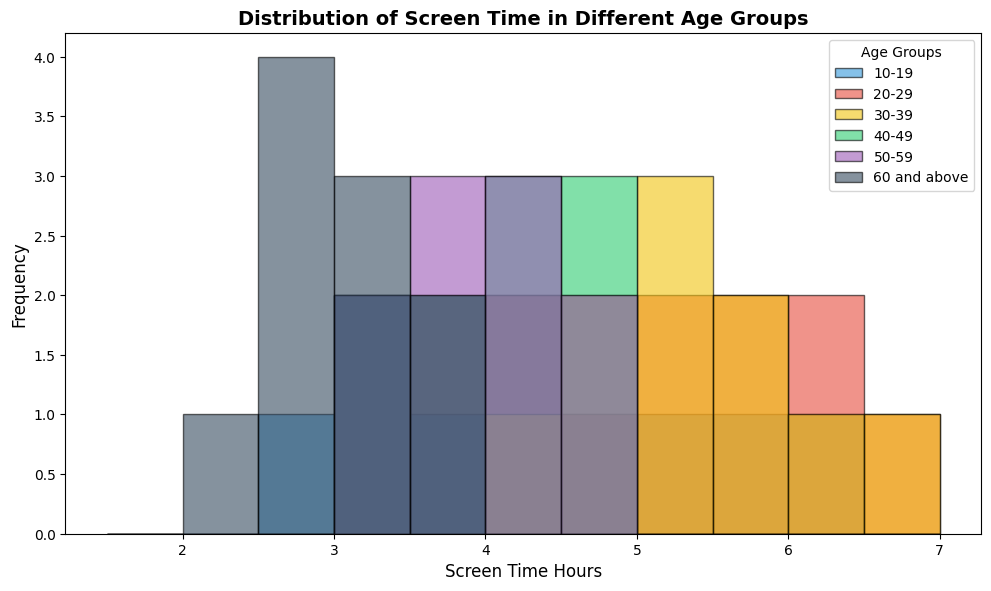Which age group has the highest peak in screen time distribution? By visually inspecting the histogram, the age group 20-29 has the highest peak in screen time distribution. This can be identified as the tallest bar segment in the histogram.
Answer: 20-29 Which age group shows the lowest screen time hours more frequently? The "60 and above" age group has more frequent lower screen time hours. This is evident from the more frequent bars at the lower end (e.g., 2.0 and 2.5 hours) of their distribution in the histogram.
Answer: 60 and above What is the most common screen time range for the 30-39 age group? By looking at the bins in the histogram for the 30-39 age group, the most common screen time range for this group falls around 5.0 hours, as it contains higher bars in this category.
Answer: 5.0 hours Between the 40-49 and 50-59 age groups, which one shows higher median screen time? The "40-49" age group has their histogram bars concentrated more towards 4.0-4.5 hours, whereas the "50-59" age group has bars more evenly distributed without a clear higher concentration. Hence, "40-49" has a higher median screen time.
Answer: 40-49 Which age group has the broadest distribution of screen time hours? By examining the width of the bar spread in the histogram, the "20-29" age group has a broader distribution, spanning from 4.0 to 6.5 hours. This indicates a wider range of screen time hours compared to other groups.
Answer: 20-29 Are there any age groups that have screen time hours exceeding 6.0 hours? By observing the histogram, only the "20-29" age group has screen time hours exceeding 6.0, specifically reaching up to 6.5 hours.
Answer: Yes Which age group's screen time distribution is predominantly below 4.0 hours? The "60 and above" age group's screen time distribution is predominantly below 4.0 hours, as represented by most of its bars being clustered at the lower end of the histogram.
Answer: 60 and above For the 10-19 age group, is there any screen time distribution equivalency, meaning two equal frequency bars? In the histogram for the 10-19 age group, there are two bars for 3.0 hours and 4.0 hours, both having the same height, indicating equal frequency.
Answer: Yes Is there any age group that has a multi-modal distribution, showing multiple peaks? By examining the histogram, the "20-29" age group shows a multi-modal distribution with peaks around 4.0, 5.0, and 6.0 screen time hours.
Answer: Yes 